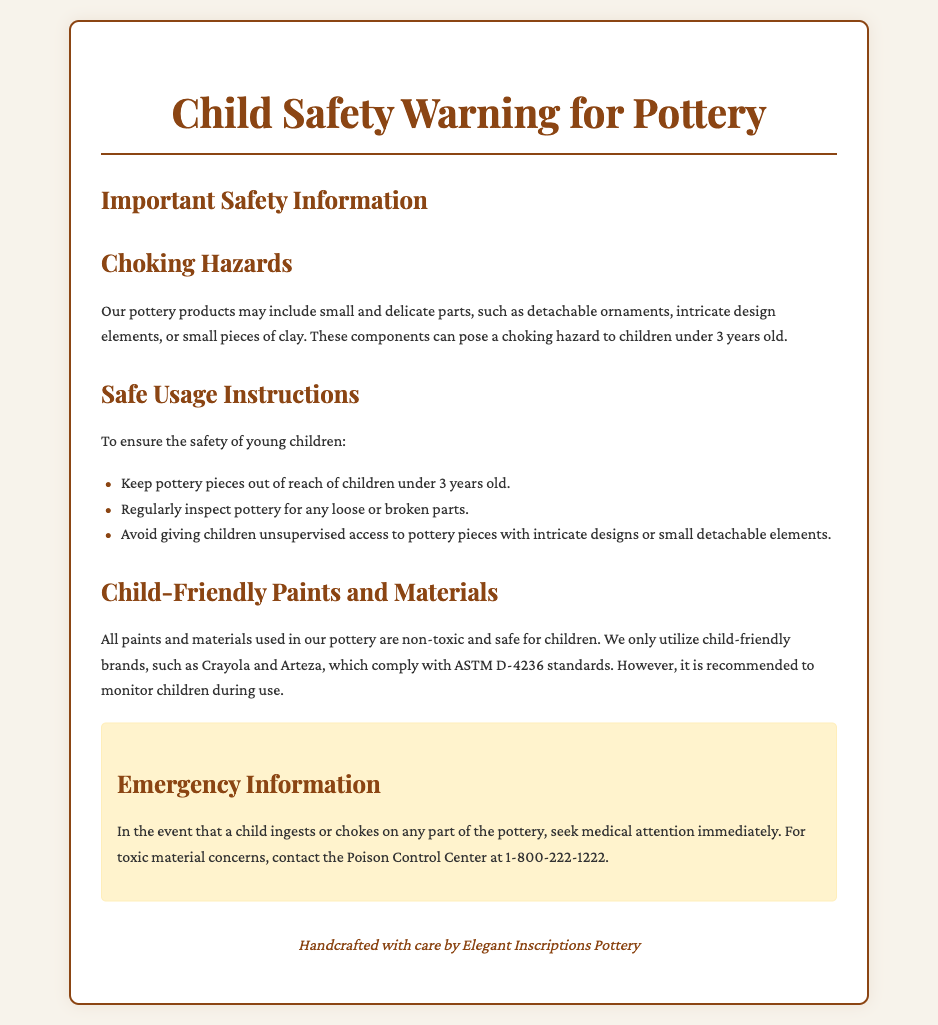What is the recommended age for supervision with pottery? The document states that pottery pieces should be kept out of reach of children under 3 years old.
Answer: 3 years old What should you do if a child ingests a part of the pottery? The document advises to seek medical attention immediately.
Answer: Seek medical attention Which brands of paints are mentioned as child-friendly? The document mentions Crayola and Arteza as child-friendly brands.
Answer: Crayola and Arteza What standard do the non-toxic paints comply with? The document states that the paints comply with ASTM D-4236 standards.
Answer: ASTM D-4236 What type of hazards do small and delicate parts pose? The small and delicate parts can pose a choking hazard to children.
Answer: Choking hazard How often should pottery be inspected? The document suggests to regularly inspect pottery for any loose or broken parts.
Answer: Regularly What color is the emergency information box? The emergency information box has a background color of light yellow.
Answer: Light yellow What is the primary concern for children under three years old? The document highlights choking hazards as a primary concern.
Answer: Choking hazards What is included in the emergency contact information? The contact information provided is for the Poison Control Center at 1-800-222-1222.
Answer: Poison Control Center at 1-800-222-1222 